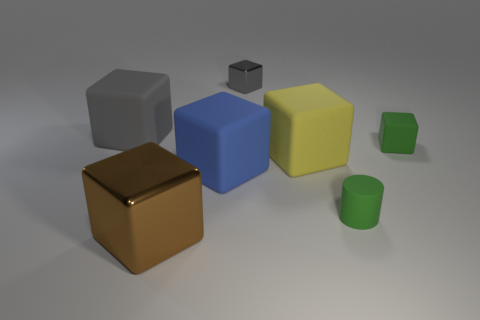What number of yellow rubber things have the same shape as the large shiny object?
Offer a terse response. 1. What is the material of the block that is the same color as the tiny matte cylinder?
Provide a succinct answer. Rubber. There is a brown thing; does it have the same shape as the small shiny object that is behind the yellow rubber thing?
Offer a terse response. Yes. What material is the big yellow thing that is the same shape as the gray shiny object?
Your answer should be very brief. Rubber. There is a gray thing on the right side of the large brown metal thing; is it the same shape as the large shiny thing?
Offer a very short reply. Yes. The other cube that is the same color as the tiny metallic cube is what size?
Your response must be concise. Large. There is a small object that is behind the large thing behind the yellow object; are there any large gray cubes that are in front of it?
Offer a terse response. Yes. Are there any tiny green cylinders left of the yellow matte object?
Give a very brief answer. No. There is a yellow block that is right of the large gray cube; how many gray metal blocks are right of it?
Ensure brevity in your answer.  0. Is the size of the gray metallic thing the same as the rubber object left of the big blue matte cube?
Your answer should be very brief. No. 